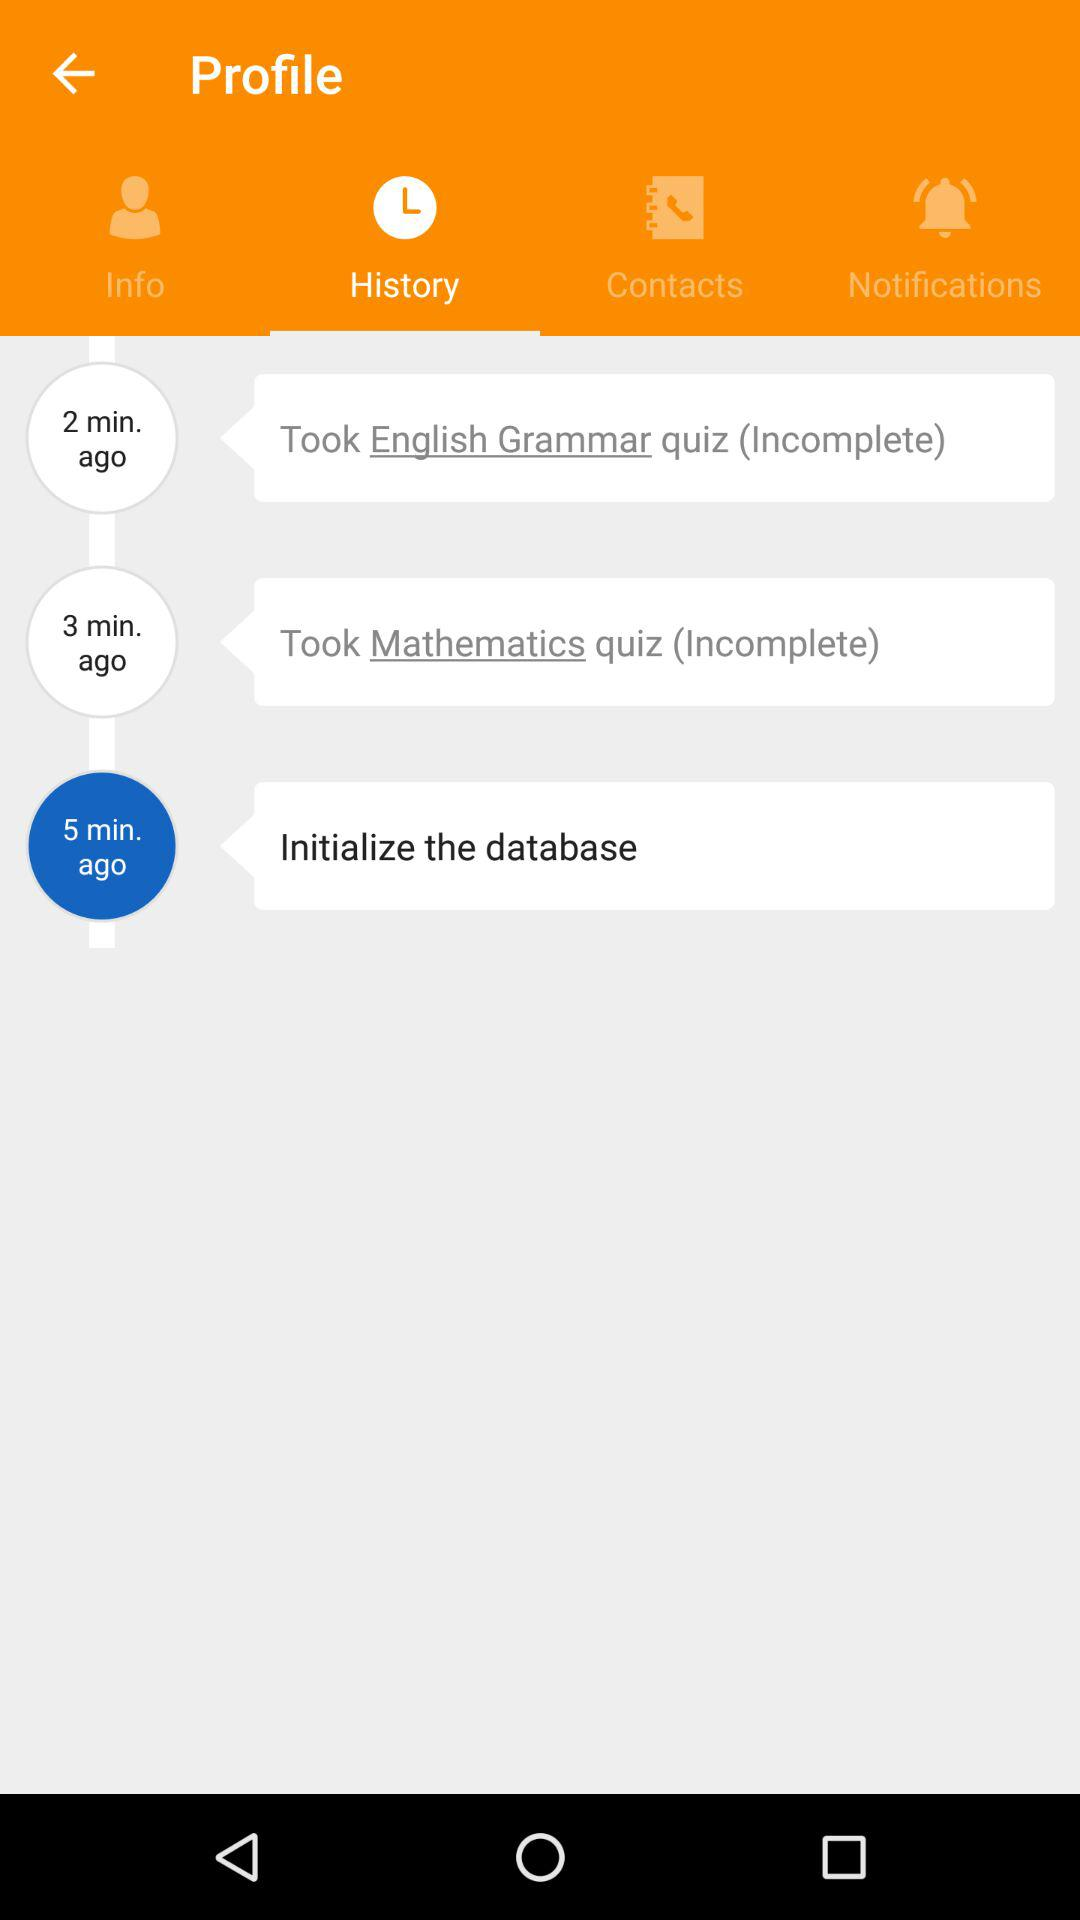Which tab is selected? The selected tab is "History". 